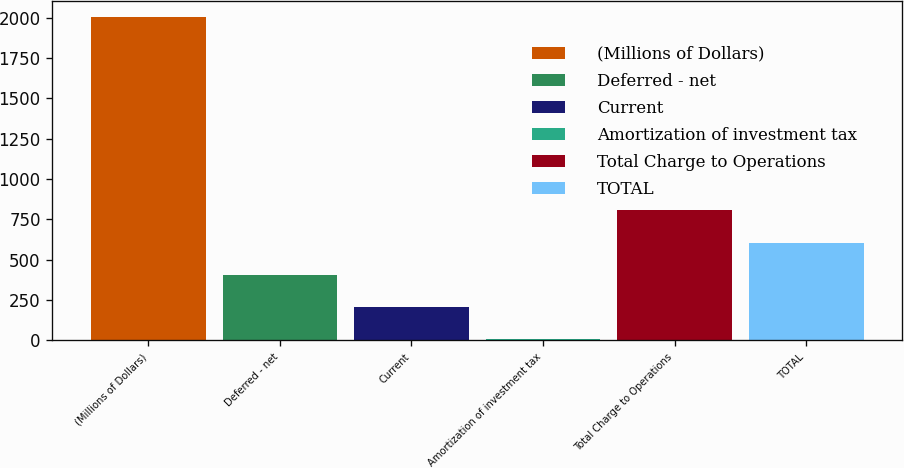Convert chart. <chart><loc_0><loc_0><loc_500><loc_500><bar_chart><fcel>(Millions of Dollars)<fcel>Deferred - net<fcel>Current<fcel>Amortization of investment tax<fcel>Total Charge to Operations<fcel>TOTAL<nl><fcel>2006<fcel>406<fcel>206<fcel>6<fcel>806<fcel>606<nl></chart> 